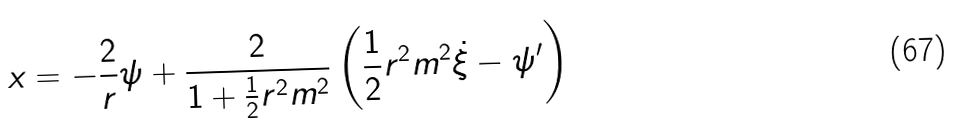<formula> <loc_0><loc_0><loc_500><loc_500>x = - \frac { 2 } { r } \psi + \frac { 2 } { 1 + \frac { 1 } { 2 } r ^ { 2 } m ^ { 2 } } \left ( \frac { 1 } { 2 } r ^ { 2 } m ^ { 2 } \dot { \xi } - \psi ^ { \prime } \right )</formula> 